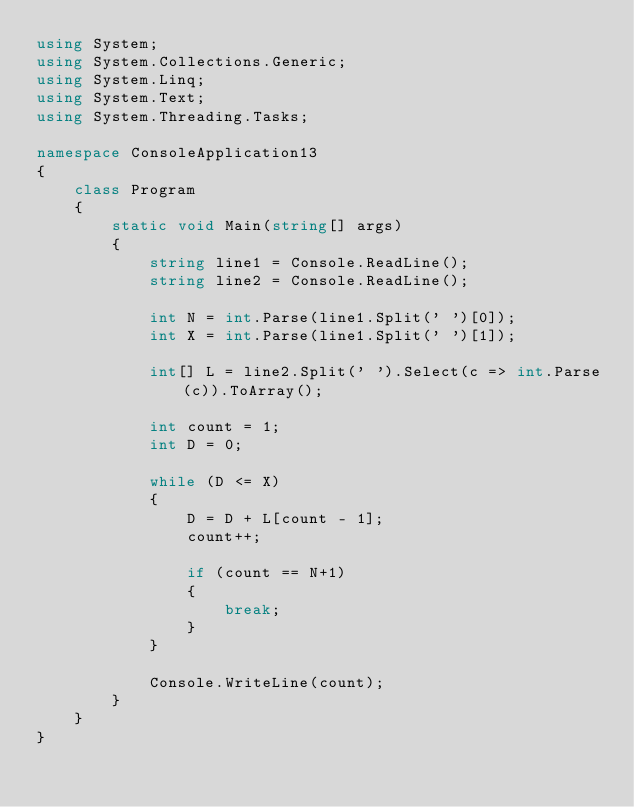Convert code to text. <code><loc_0><loc_0><loc_500><loc_500><_C#_>using System;
using System.Collections.Generic;
using System.Linq;
using System.Text;
using System.Threading.Tasks;

namespace ConsoleApplication13
{
    class Program
    {
        static void Main(string[] args)
        {
            string line1 = Console.ReadLine();
            string line2 = Console.ReadLine();

            int N = int.Parse(line1.Split(' ')[0]);
            int X = int.Parse(line1.Split(' ')[1]);

            int[] L = line2.Split(' ').Select(c => int.Parse(c)).ToArray();

            int count = 1;
            int D = 0;

            while (D <= X)
            {
                D = D + L[count - 1];
                count++;

                if (count == N+1)
                {
                    break;
                }
            }

            Console.WriteLine(count);
        }
    }
}
</code> 